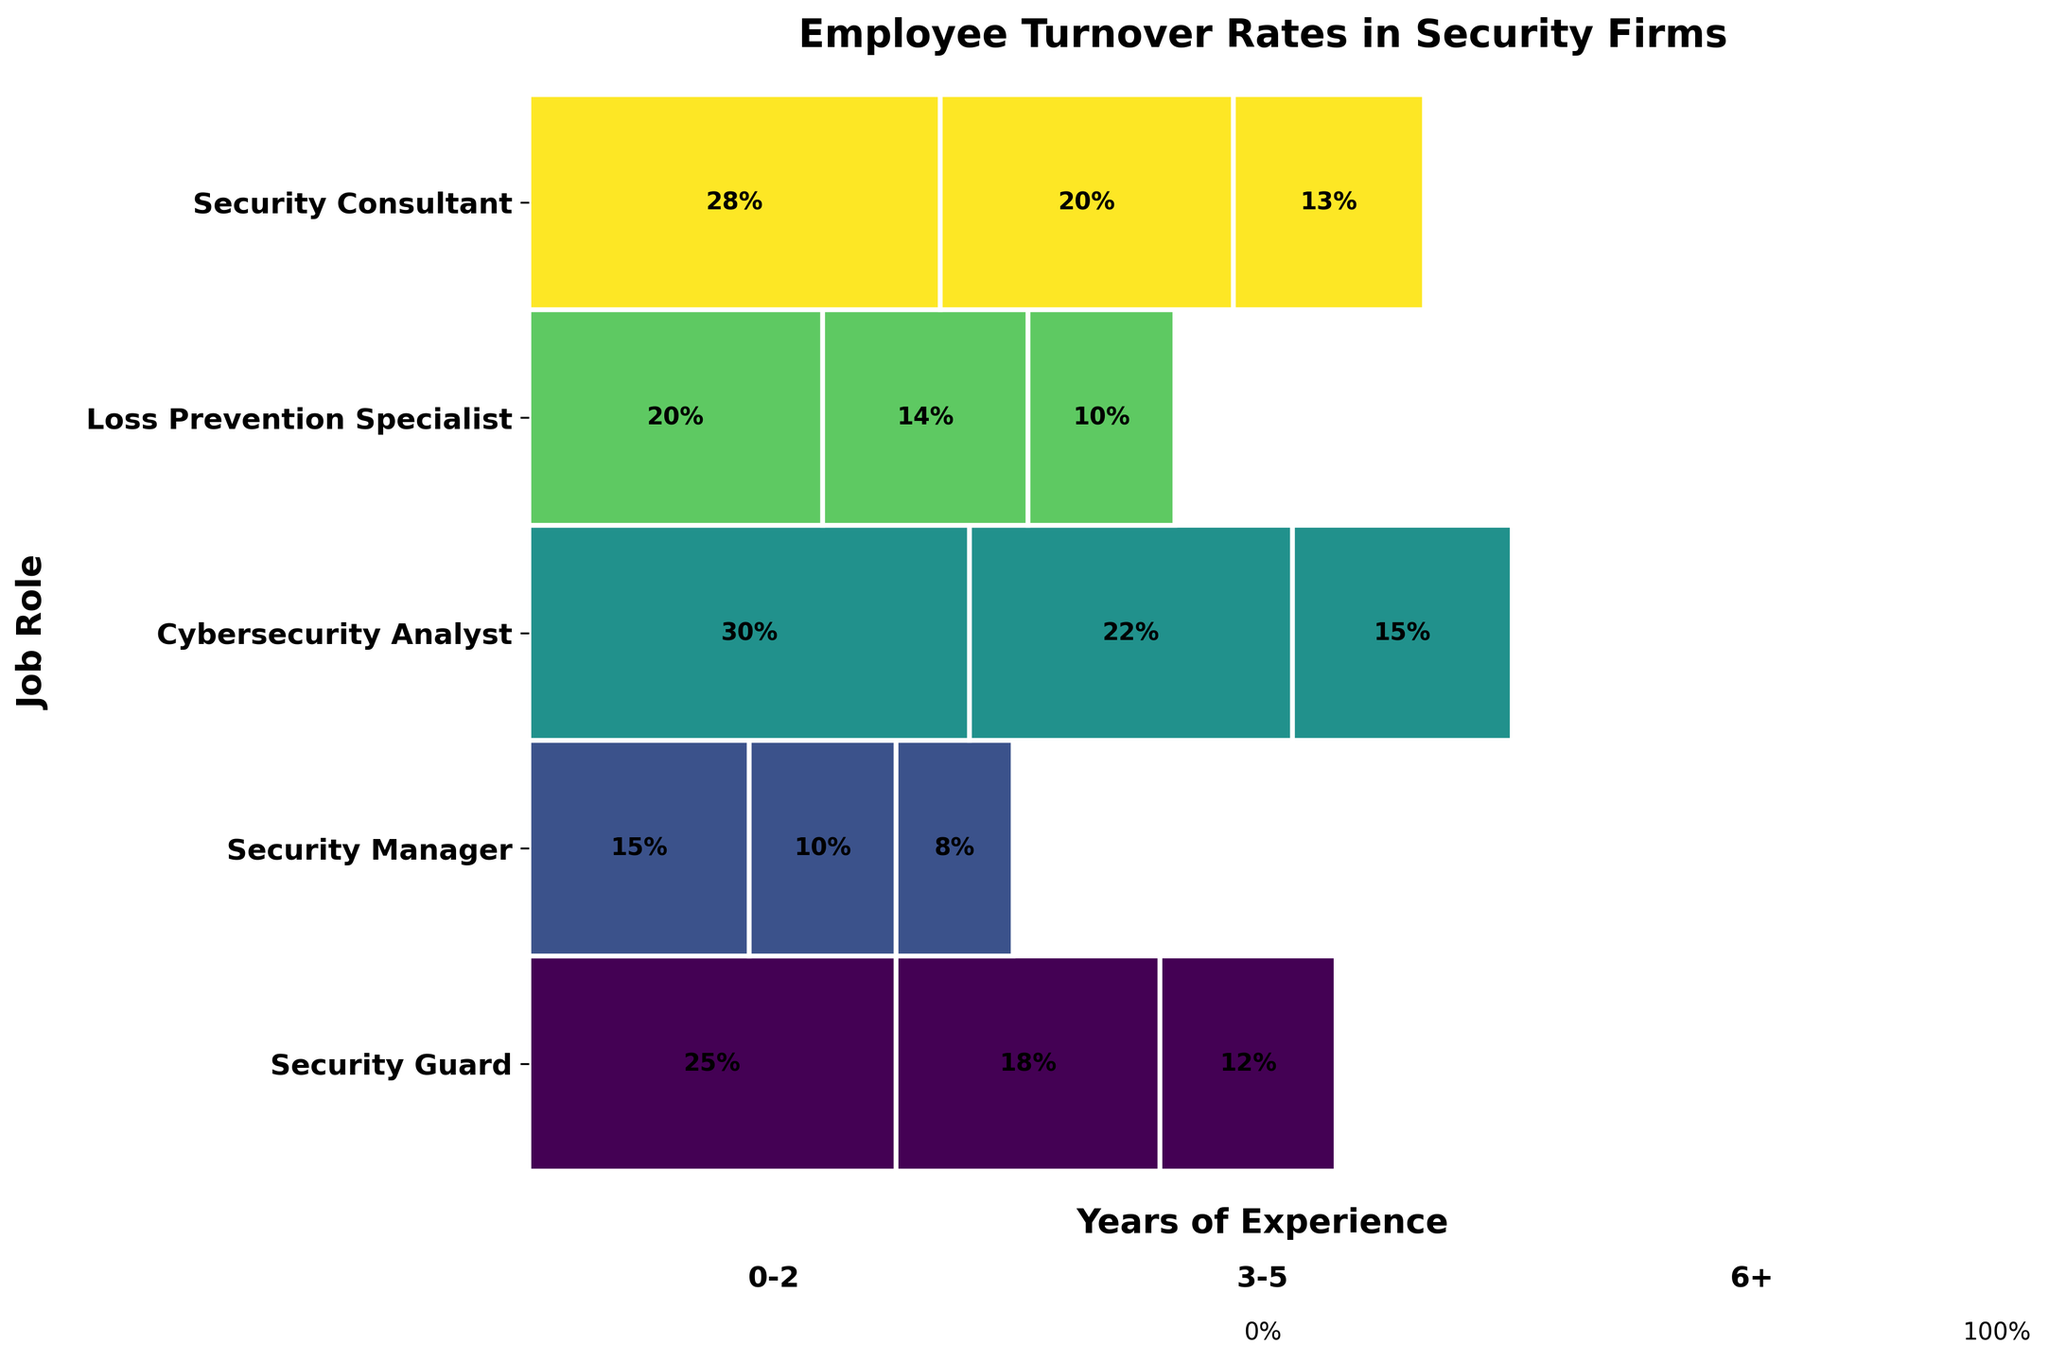Which job role has the highest turnover rate for employees with 0-2 years of experience? The job role with the highest turnover rate can be identified by looking at the size of the colored sections in the "0-2 years" portion of the figure.
Answer: Cybersecurity Analyst Which job role has the lowest turnover rate for employees with 6+ years of experience? The job role with the lowest turnover rate can be identified by looking at the size of the colored sections in the "6+ years" portion of the figure.
Answer: Security Manager What's the average turnover rate for Security Guards across all years of experience? To find the average, sum the turnover rates for Security Guards (25% + 18% + 12%) and divide by the number of experience levels (3).
Answer: 18.3% What is the difference in turnover rates between Cybersecurity Analysts with 0-2 years and 6+ years of experience? Subtract the turnover rate of Cybersecurity Analysts with 6+ years of experience (15%) from those with 0-2 years of experience (30%).
Answer: 15% How do turnover rates for Security Consultants with 3-5 years compare to those with 6+ years of experience? Compare the turnover rates of Security Consultants with 3-5 years (20%) and 6+ years (13%) of experience.
Answer: Higher Are turnover rates generally higher for employees with less experience across all job roles? Compare the turnover rates of employees with 0-2 years, 3-5 years, and 6+ years of experience across all job roles. The general trend shows higher rates for those with less experience.
Answer: Yes Which job role has the smallest decrease in turnover rate from 0-2 years to 6+ years? Calculate the decrease in turnover rate from 0-2 years to 6+ years for each job role and find the smallest value.
Answer: Loss Prevention Specialist What is the average turnover rate for all job roles combined across all years of experience? Sum all the turnover rates and divide by the number of data points (15).
Answer: 16.8% How does the turnover rate for Security Managers with 0-2 years compare to Loss Prevention Specialists with the same experience? Compare the turnover rates of Security Managers (15%) and Loss Prevention Specialists (20%) with 0-2 years of experience.
Answer: Lower What is the range of turnover rates for Security Guards? Find the difference between the highest (25%) and the lowest (12%) turnover rates for Security Guards.
Answer: 13% 